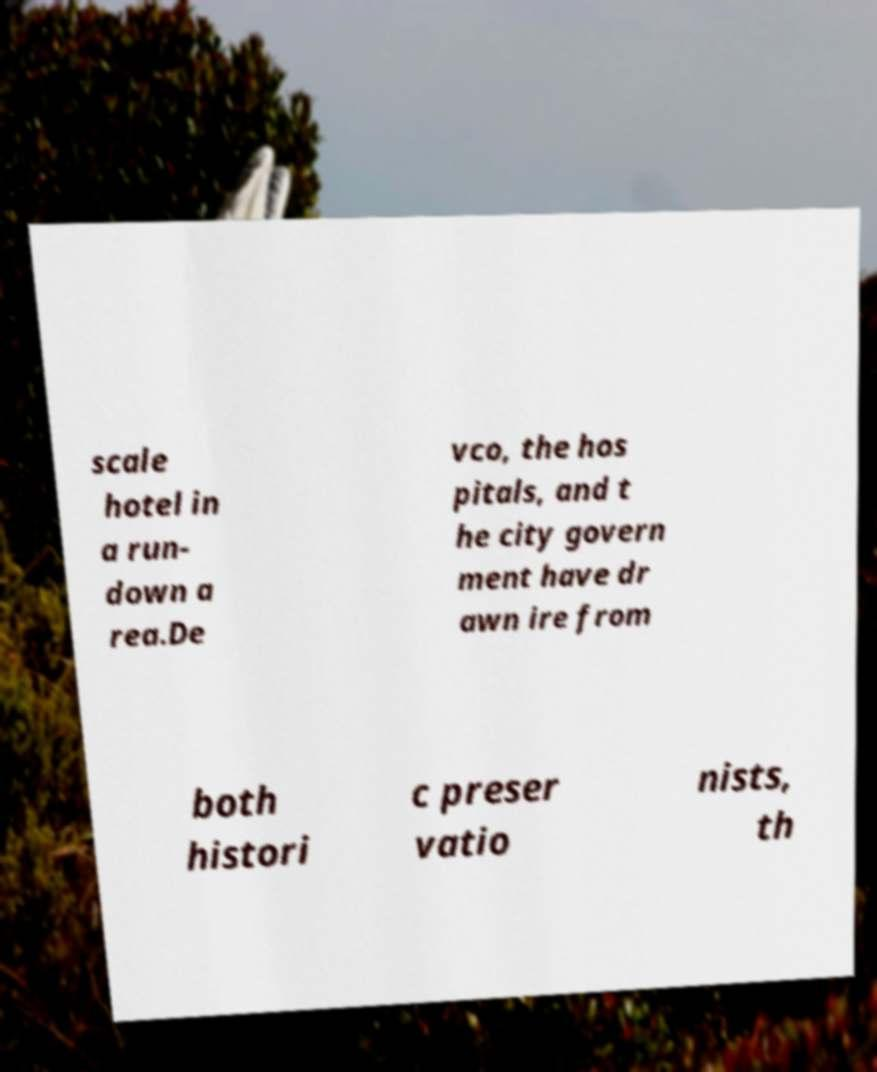There's text embedded in this image that I need extracted. Can you transcribe it verbatim? scale hotel in a run- down a rea.De vco, the hos pitals, and t he city govern ment have dr awn ire from both histori c preser vatio nists, th 